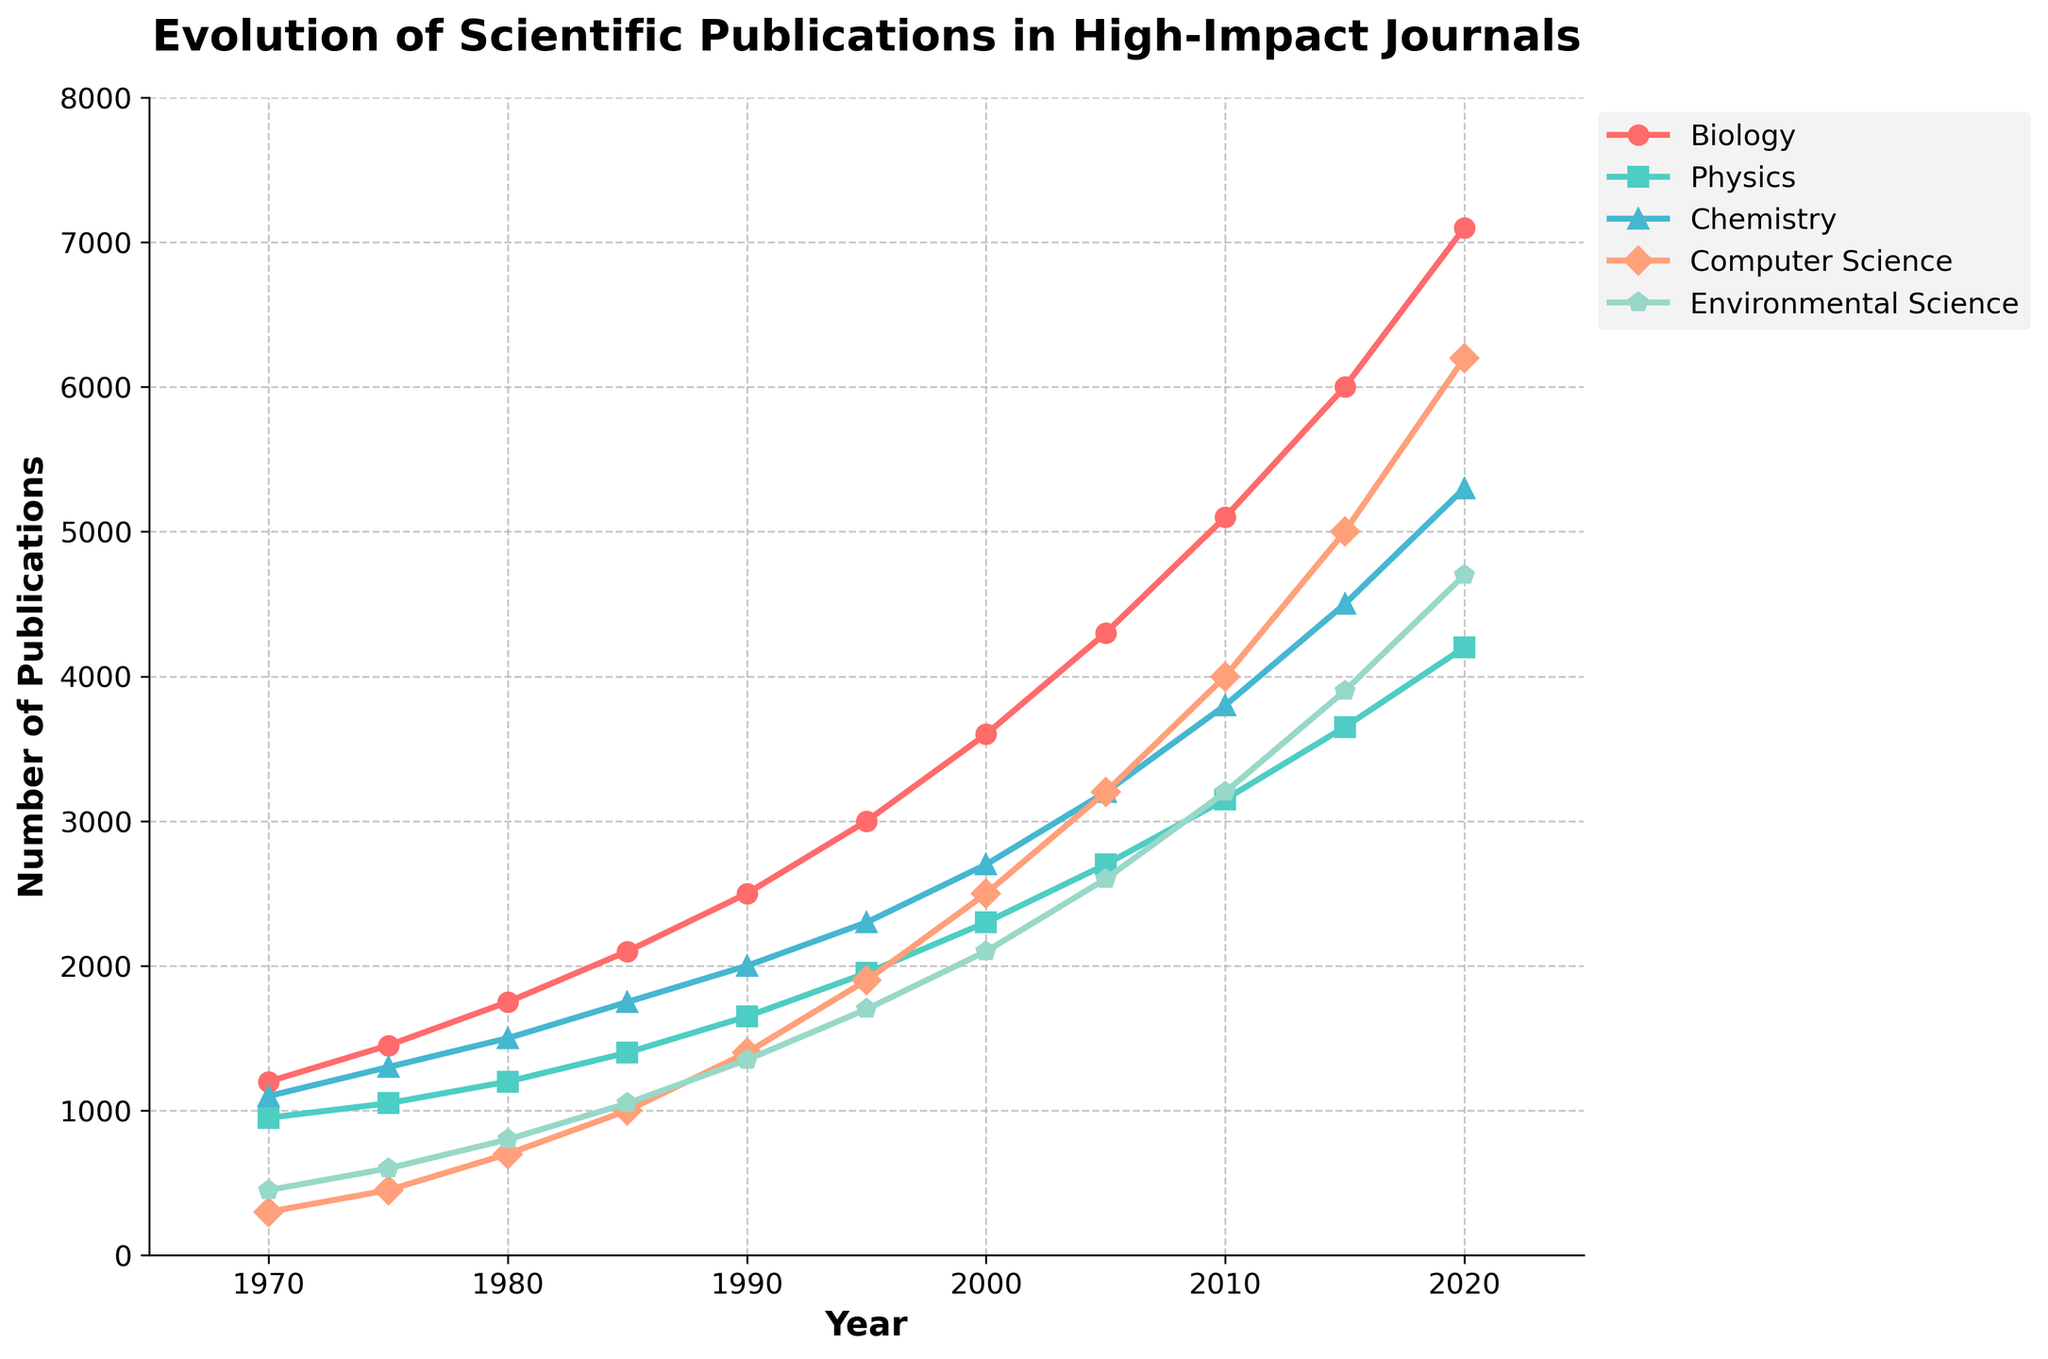What is the trend for the number of Biology publications from 1970 to 2020? The line representing Biology publications shows a clear upward trend from 1200 in 1970 to 7100 in 2020.
Answer: Increasing Which research area had the second highest number of publications in 2010? The figure shows that Computer Science had the second highest number of publications in 2010, with around 4000, after Biology.
Answer: Computer Science How many more Biology publications were there in 2020 compared to 1990? In 2020, there were 7100 Biology publications, and in 1990 there were 2500. The difference is 7100 - 2500 = 4600.
Answer: 4600 Which research area shows the most rapid increase in publications from 2005 to 2015? From the figure, Computer Science publications increased from 3200 in 2005 to 5000 in 2015, showing a rapid increase of 1800 publications.
Answer: Computer Science In which year did Physics publications exceed 3000 for the first time? The figure shows Physics publications first exceeding 3000 in the year 2015.
Answer: 2015 What is the combined total number of publications in 2020 for Chemistry and Environmental Science? In 2020, Chemistry had 5300 publications and Environmental Science had 4700. The combined total is 5300 + 4700 = 10000.
Answer: 10000 Which two research areas had the closest number of publications in 2000? In 2000, Chemistry had 2700 publications and Physics had 2300, with a difference of 400, making them the closest.
Answer: Chemistry and Physics Did the number of Environmental Science publications ever surpass the number of Chemistry publications within the 50-year span? In the figure, at no point do the Environmental Science publications surpass the Chemistry publications within the given years.
Answer: No What is the average number of Computer Science publications from 1970 to 2020? Summing the Computer Science publications from 1970 to 2020 gives (300+450+700+1000+1400+1900+2500+3200+4000+5000+6200) = 26950. Dividing by 11 years, the average is 26950 / 11 ≈ 2450.
Answer: 2450 